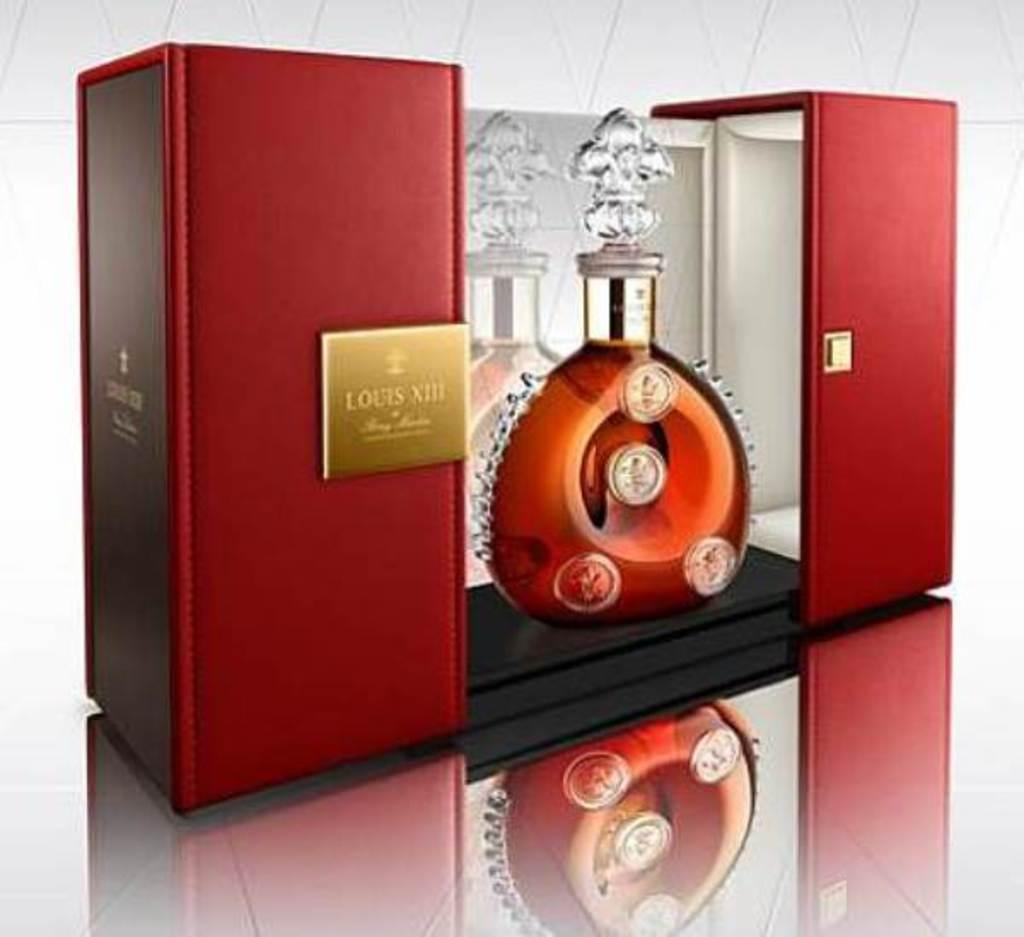<image>
Offer a succinct explanation of the picture presented. Red box with the name Louis XIII on it with a bottle in between. 